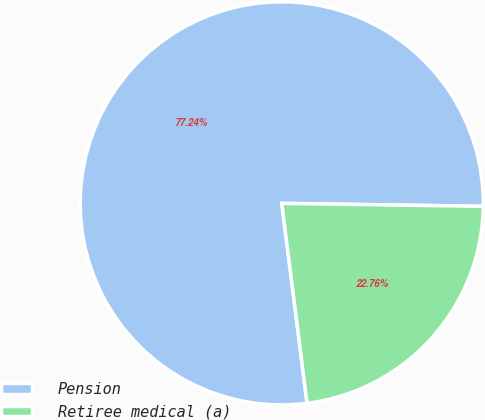Convert chart. <chart><loc_0><loc_0><loc_500><loc_500><pie_chart><fcel>Pension<fcel>Retiree medical (a)<nl><fcel>77.24%<fcel>22.76%<nl></chart> 